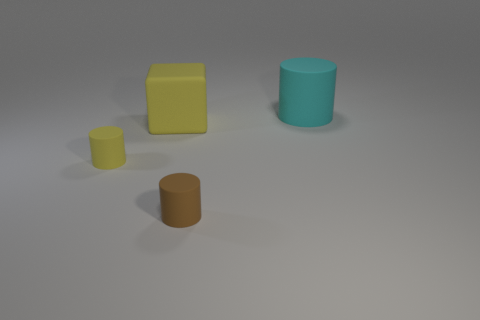Subtract all cyan rubber cylinders. How many cylinders are left? 2 Add 1 brown matte things. How many objects exist? 5 Subtract all yellow cylinders. How many cylinders are left? 2 Subtract all cylinders. How many objects are left? 1 Subtract all matte blocks. Subtract all blue cylinders. How many objects are left? 3 Add 4 cyan cylinders. How many cyan cylinders are left? 5 Add 4 big blue spheres. How many big blue spheres exist? 4 Subtract 0 green cubes. How many objects are left? 4 Subtract 1 cylinders. How many cylinders are left? 2 Subtract all brown cylinders. Subtract all gray spheres. How many cylinders are left? 2 